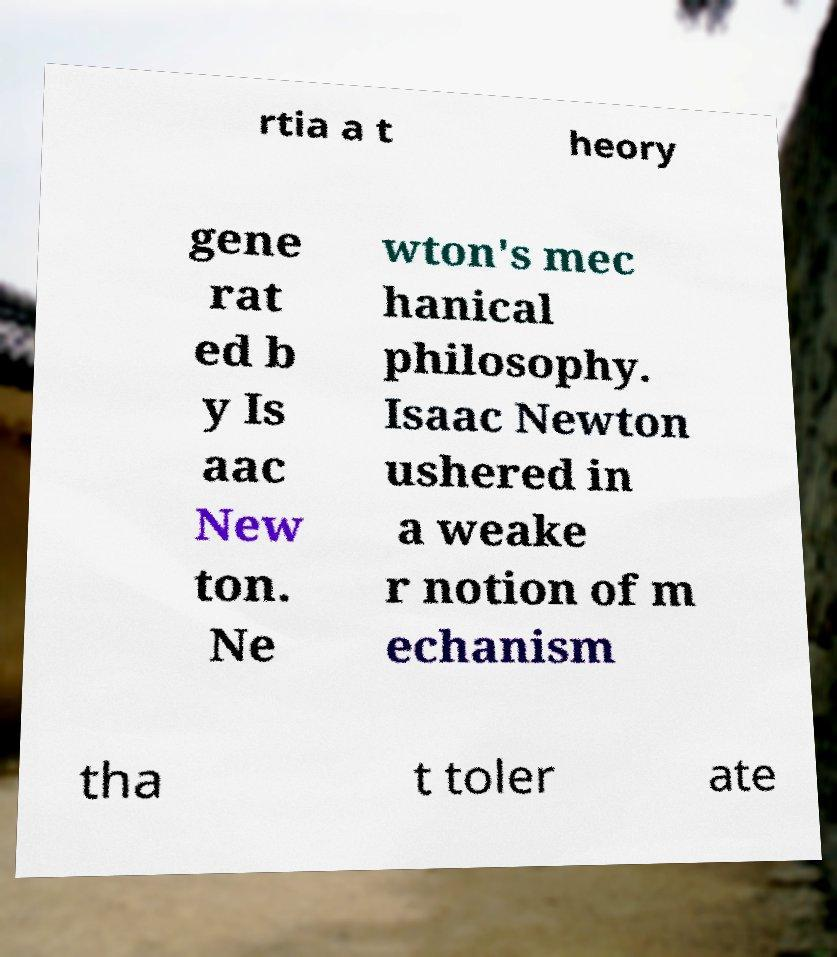What messages or text are displayed in this image? I need them in a readable, typed format. rtia a t heory gene rat ed b y Is aac New ton. Ne wton's mec hanical philosophy. Isaac Newton ushered in a weake r notion of m echanism tha t toler ate 